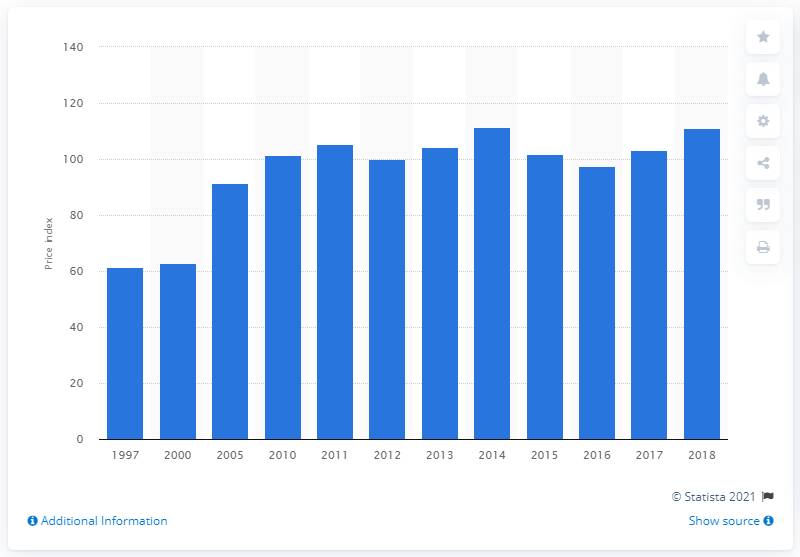Specify some key components in this picture. In 2018, the index of energy costs in the subsector was 111.03. 